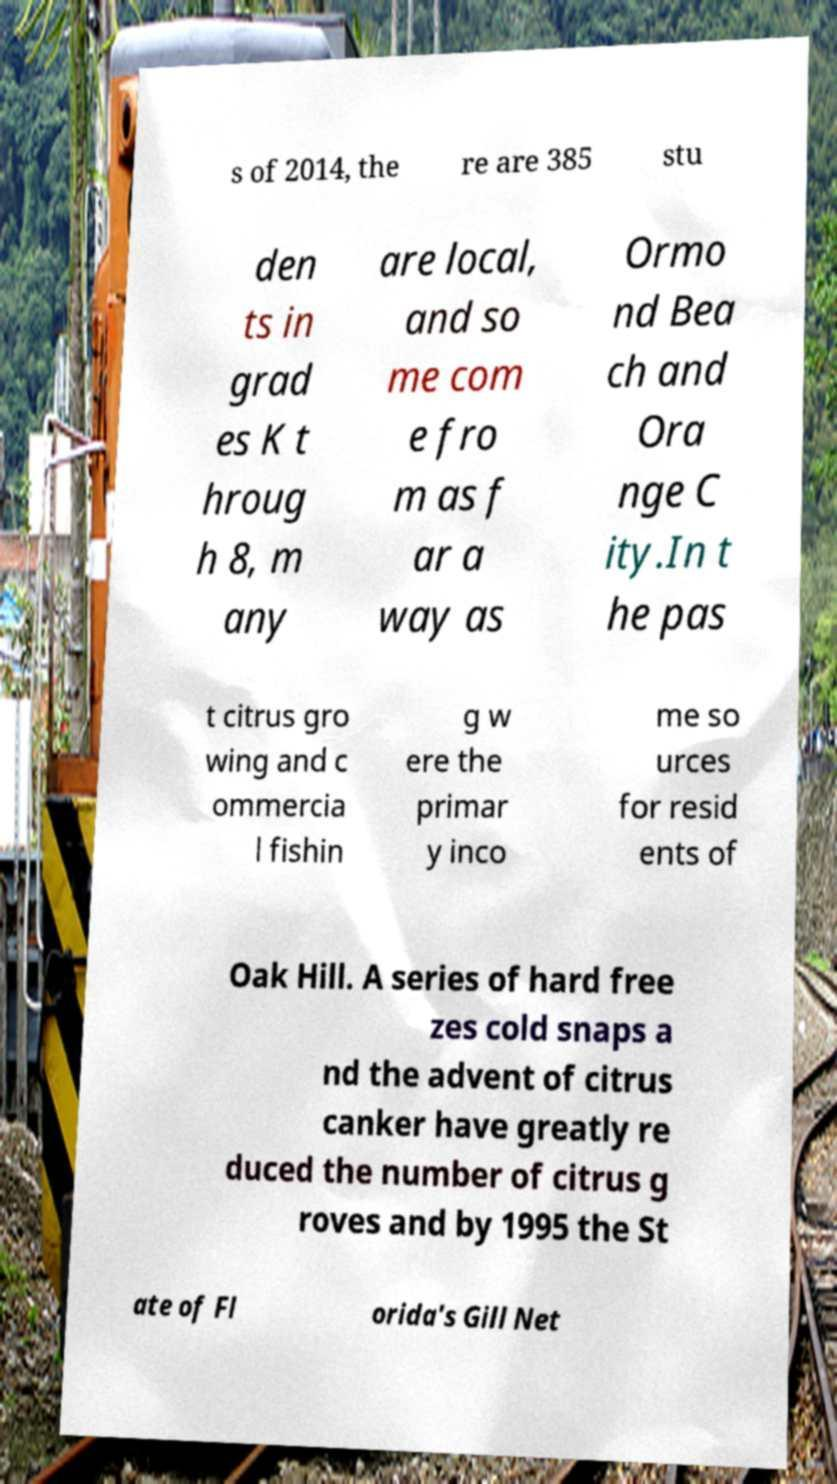Could you extract and type out the text from this image? s of 2014, the re are 385 stu den ts in grad es K t hroug h 8, m any are local, and so me com e fro m as f ar a way as Ormo nd Bea ch and Ora nge C ity.In t he pas t citrus gro wing and c ommercia l fishin g w ere the primar y inco me so urces for resid ents of Oak Hill. A series of hard free zes cold snaps a nd the advent of citrus canker have greatly re duced the number of citrus g roves and by 1995 the St ate of Fl orida's Gill Net 